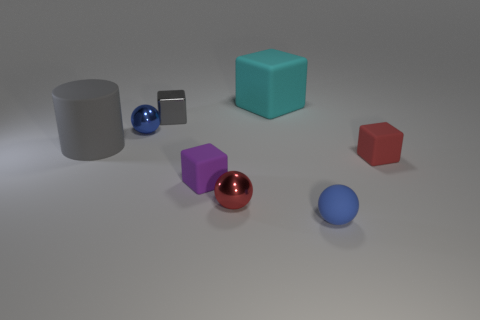Are there any other things of the same color as the shiny block?
Make the answer very short. Yes. There is a block that is both to the left of the large cyan object and behind the tiny blue shiny thing; what size is it?
Give a very brief answer. Small. Does the metallic ball that is behind the purple rubber object have the same color as the metal thing right of the metallic cube?
Your answer should be very brief. No. What number of other things are there of the same material as the large cylinder
Provide a succinct answer. 4. What is the shape of the matte object that is both behind the small red metal ball and to the right of the cyan matte thing?
Provide a short and direct response. Cube. Is the color of the tiny metallic block the same as the big object behind the gray matte cylinder?
Provide a short and direct response. No. There is a rubber thing behind the gray cube; is it the same size as the tiny rubber sphere?
Provide a succinct answer. No. What is the material of the tiny red object that is the same shape as the purple matte thing?
Your answer should be compact. Rubber. Is the tiny blue metal object the same shape as the small purple thing?
Make the answer very short. No. How many rubber cylinders are to the left of the ball right of the small red ball?
Keep it short and to the point. 1. 